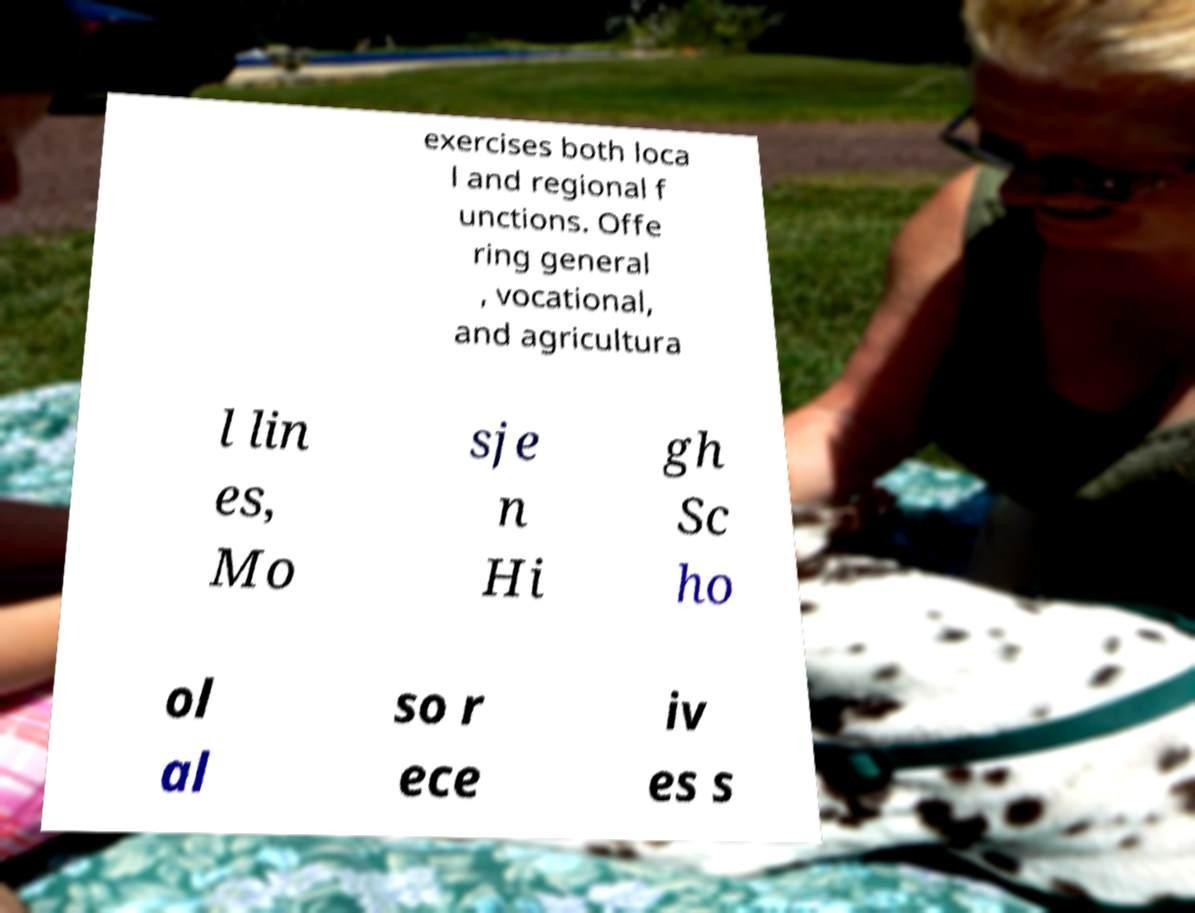For documentation purposes, I need the text within this image transcribed. Could you provide that? exercises both loca l and regional f unctions. Offe ring general , vocational, and agricultura l lin es, Mo sje n Hi gh Sc ho ol al so r ece iv es s 